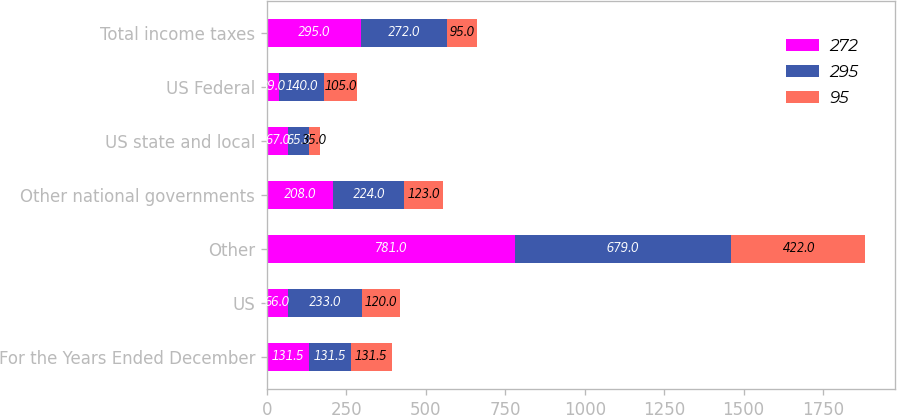<chart> <loc_0><loc_0><loc_500><loc_500><stacked_bar_chart><ecel><fcel>For the Years Ended December<fcel>US<fcel>Other<fcel>Other national governments<fcel>US state and local<fcel>US Federal<fcel>Total income taxes<nl><fcel>272<fcel>131.5<fcel>66<fcel>781<fcel>208<fcel>67<fcel>39<fcel>295<nl><fcel>295<fcel>131.5<fcel>233<fcel>679<fcel>224<fcel>65<fcel>140<fcel>272<nl><fcel>95<fcel>131.5<fcel>120<fcel>422<fcel>123<fcel>35<fcel>105<fcel>95<nl></chart> 